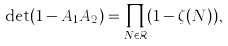Convert formula to latex. <formula><loc_0><loc_0><loc_500><loc_500>\det ( 1 - A _ { 1 } A _ { 2 } ) = \prod _ { N \in \mathcal { R } } ( 1 - \zeta ( N ) ) ,</formula> 